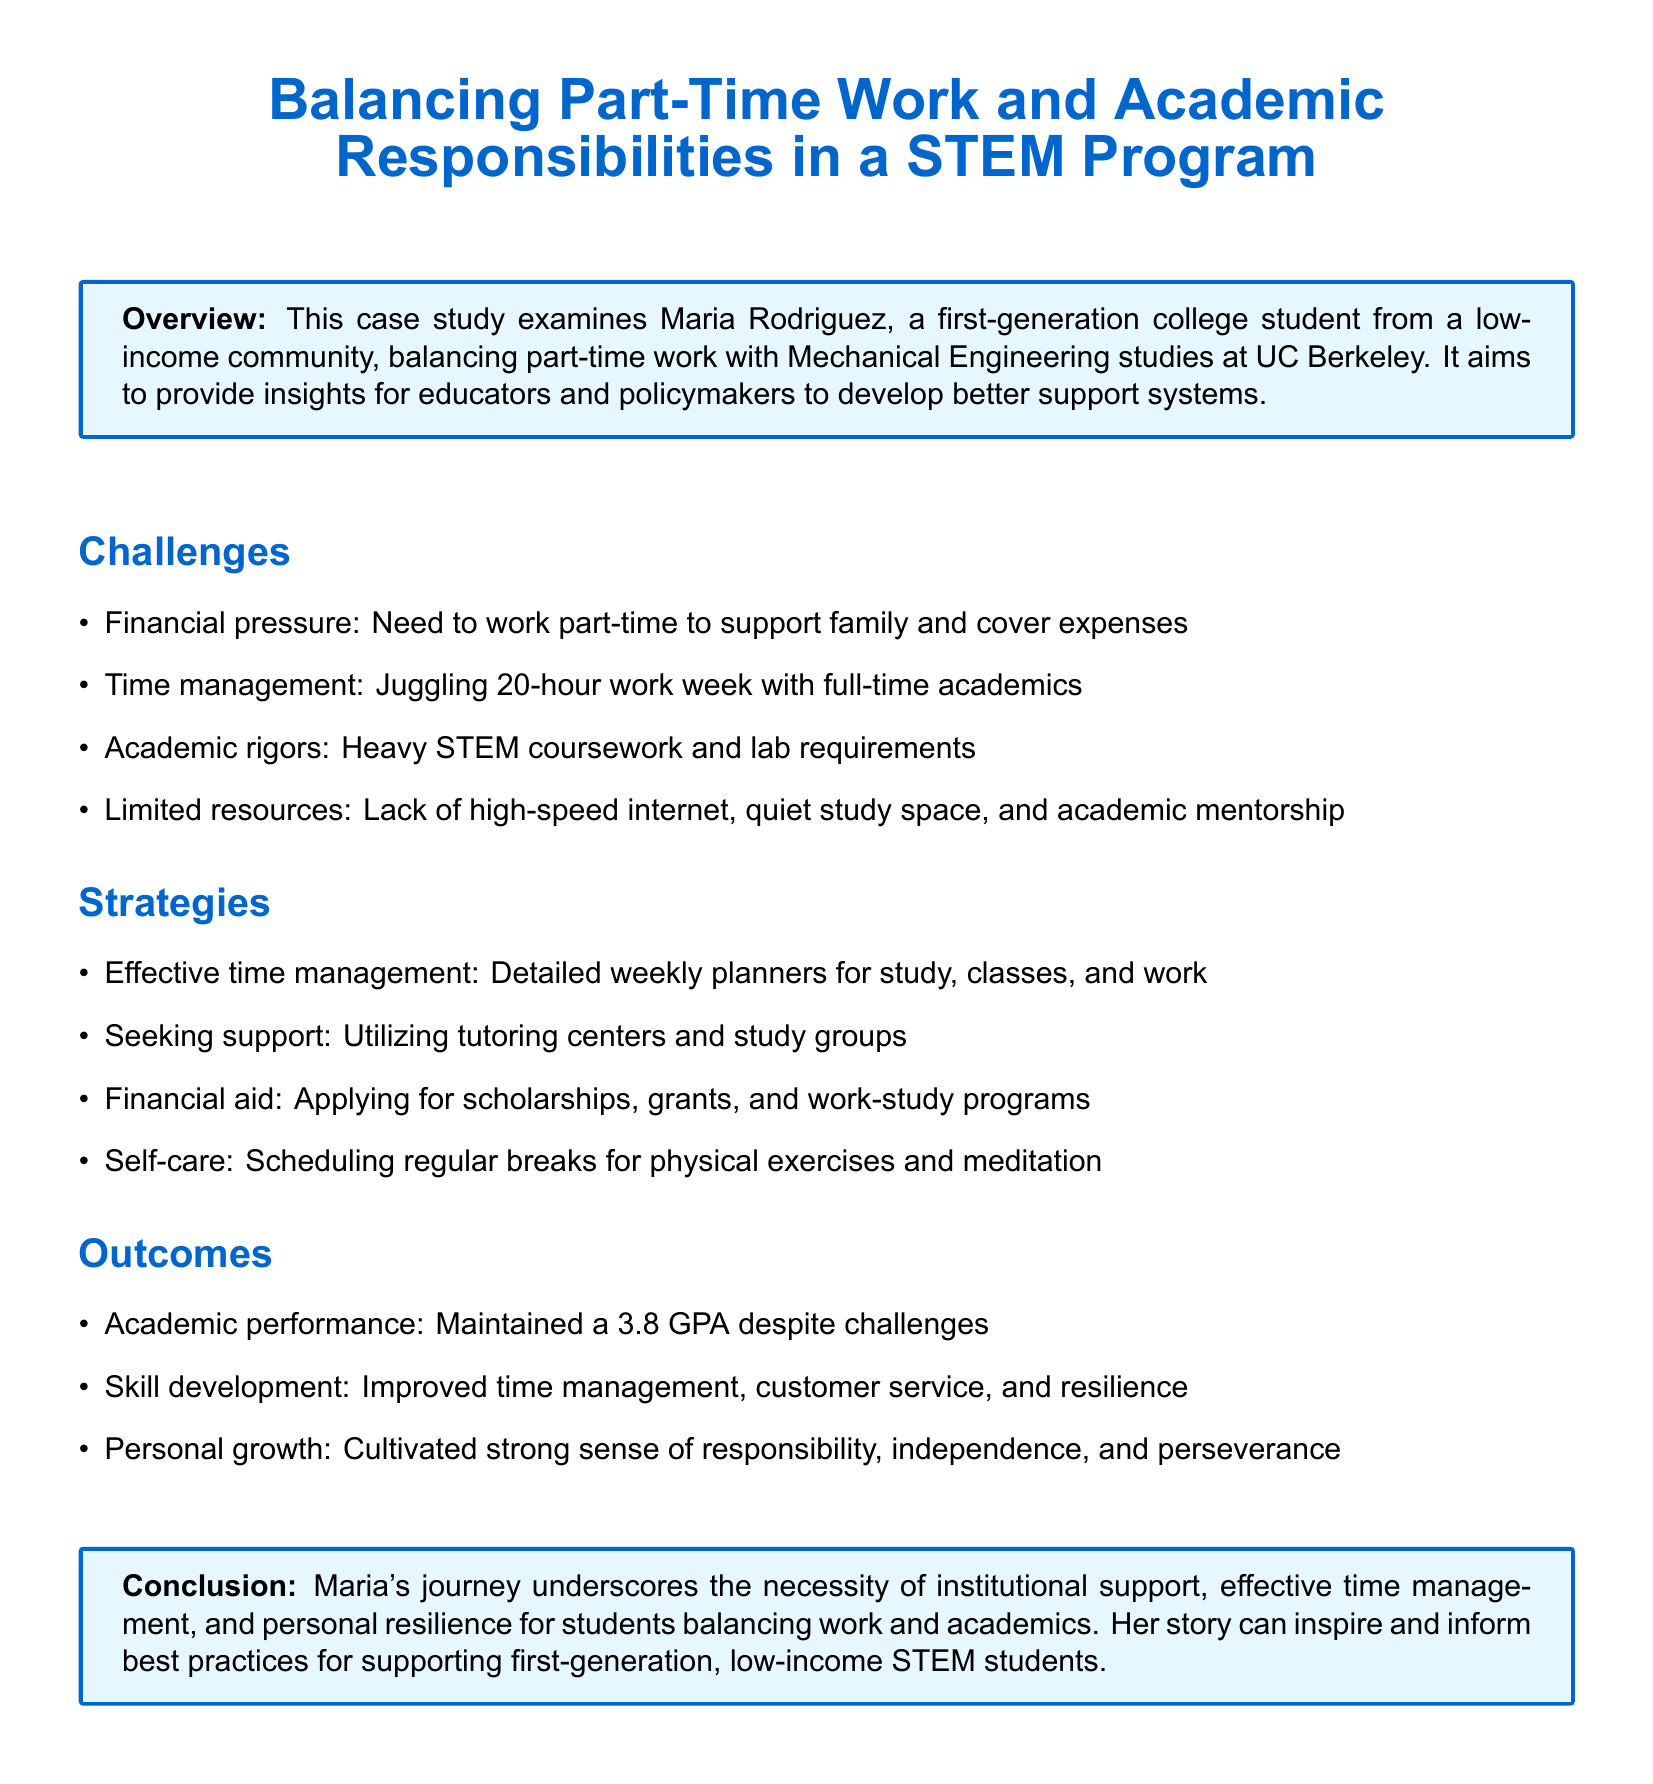What is the name of the student in the case study? The name of the student mentioned in the case study is Maria Rodriguez.
Answer: Maria Rodriguez What is Maria studying at UC Berkeley? Maria is studying Mechanical Engineering at UC Berkeley.
Answer: Mechanical Engineering What is Maria's GPA mentioned in the outcomes? The outcomes section states that Maria maintained a 3.8 GPA despite challenges.
Answer: 3.8 How many hours per week does Maria work? The challenges section indicates that Maria is juggling a 20-hour work week.
Answer: 20 hours What strategy involves using a planner? The strategy involving a planner is effective time management, which includes detailed weekly planners.
Answer: Effective time management What type of support did Maria utilize for her studies? Maria sought support by utilizing tutoring centers and study groups.
Answer: Tutoring centers and study groups What is one personal growth aspect Maria developed? One personal growth aspect that Maria cultivated is a strong sense of responsibility.
Answer: Responsibility What financial aid options did Maria apply for? Maria applied for scholarships, grants, and work-study programs as financial aid options.
Answer: Scholarships, grants, and work-study What does the conclusion emphasize as necessary for students? The conclusion emphasizes the necessity of institutional support for students balancing work and academics.
Answer: Institutional support 